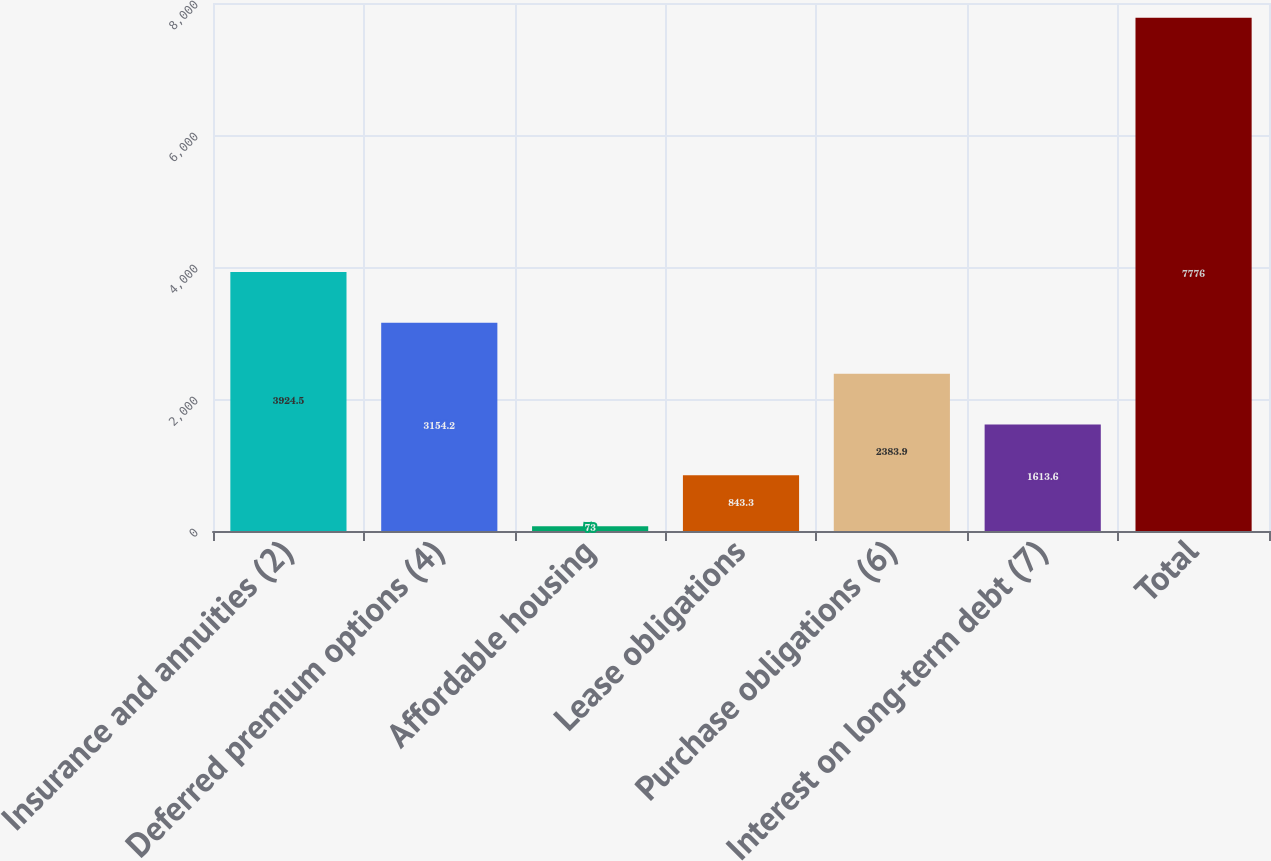Convert chart to OTSL. <chart><loc_0><loc_0><loc_500><loc_500><bar_chart><fcel>Insurance and annuities (2)<fcel>Deferred premium options (4)<fcel>Affordable housing<fcel>Lease obligations<fcel>Purchase obligations (6)<fcel>Interest on long-term debt (7)<fcel>Total<nl><fcel>3924.5<fcel>3154.2<fcel>73<fcel>843.3<fcel>2383.9<fcel>1613.6<fcel>7776<nl></chart> 